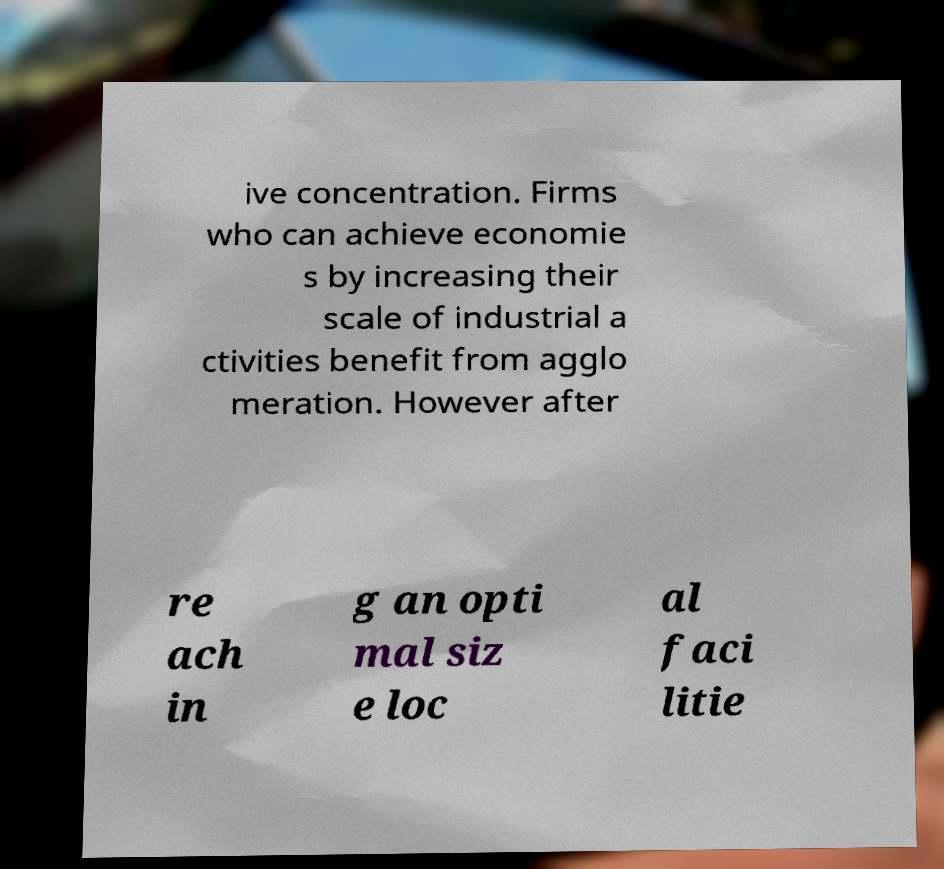Please read and relay the text visible in this image. What does it say? ive concentration. Firms who can achieve economie s by increasing their scale of industrial a ctivities benefit from agglo meration. However after re ach in g an opti mal siz e loc al faci litie 